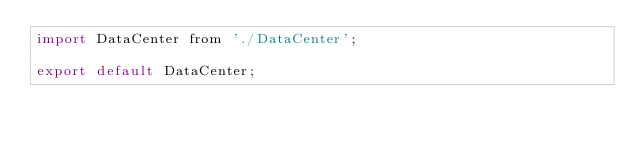Convert code to text. <code><loc_0><loc_0><loc_500><loc_500><_JavaScript_>import DataCenter from './DataCenter';

export default DataCenter;
</code> 